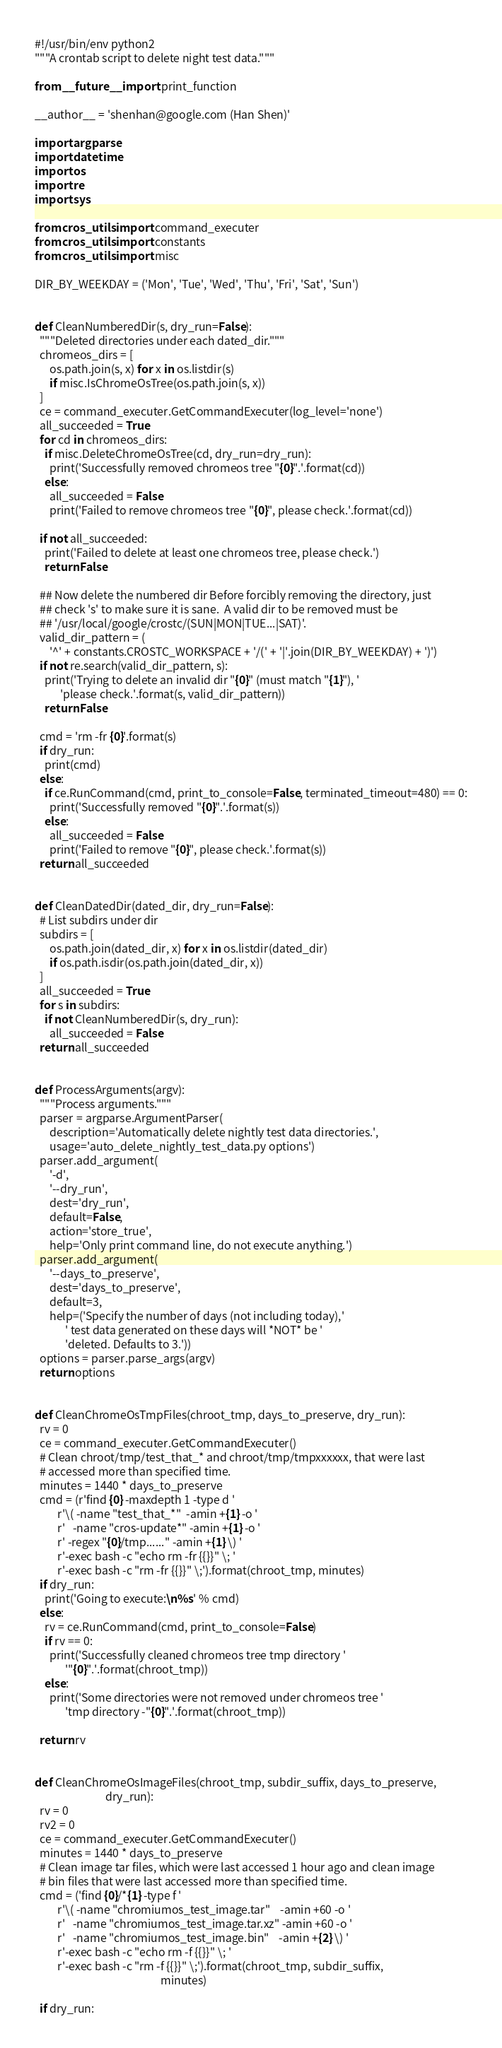<code> <loc_0><loc_0><loc_500><loc_500><_Python_>#!/usr/bin/env python2
"""A crontab script to delete night test data."""

from __future__ import print_function

__author__ = 'shenhan@google.com (Han Shen)'

import argparse
import datetime
import os
import re
import sys

from cros_utils import command_executer
from cros_utils import constants
from cros_utils import misc

DIR_BY_WEEKDAY = ('Mon', 'Tue', 'Wed', 'Thu', 'Fri', 'Sat', 'Sun')


def CleanNumberedDir(s, dry_run=False):
  """Deleted directories under each dated_dir."""
  chromeos_dirs = [
      os.path.join(s, x) for x in os.listdir(s)
      if misc.IsChromeOsTree(os.path.join(s, x))
  ]
  ce = command_executer.GetCommandExecuter(log_level='none')
  all_succeeded = True
  for cd in chromeos_dirs:
    if misc.DeleteChromeOsTree(cd, dry_run=dry_run):
      print('Successfully removed chromeos tree "{0}".'.format(cd))
    else:
      all_succeeded = False
      print('Failed to remove chromeos tree "{0}", please check.'.format(cd))

  if not all_succeeded:
    print('Failed to delete at least one chromeos tree, please check.')
    return False

  ## Now delete the numbered dir Before forcibly removing the directory, just
  ## check 's' to make sure it is sane.  A valid dir to be removed must be
  ## '/usr/local/google/crostc/(SUN|MON|TUE...|SAT)'.
  valid_dir_pattern = (
      '^' + constants.CROSTC_WORKSPACE + '/(' + '|'.join(DIR_BY_WEEKDAY) + ')')
  if not re.search(valid_dir_pattern, s):
    print('Trying to delete an invalid dir "{0}" (must match "{1}"), '
          'please check.'.format(s, valid_dir_pattern))
    return False

  cmd = 'rm -fr {0}'.format(s)
  if dry_run:
    print(cmd)
  else:
    if ce.RunCommand(cmd, print_to_console=False, terminated_timeout=480) == 0:
      print('Successfully removed "{0}".'.format(s))
    else:
      all_succeeded = False
      print('Failed to remove "{0}", please check.'.format(s))
  return all_succeeded


def CleanDatedDir(dated_dir, dry_run=False):
  # List subdirs under dir
  subdirs = [
      os.path.join(dated_dir, x) for x in os.listdir(dated_dir)
      if os.path.isdir(os.path.join(dated_dir, x))
  ]
  all_succeeded = True
  for s in subdirs:
    if not CleanNumberedDir(s, dry_run):
      all_succeeded = False
  return all_succeeded


def ProcessArguments(argv):
  """Process arguments."""
  parser = argparse.ArgumentParser(
      description='Automatically delete nightly test data directories.',
      usage='auto_delete_nightly_test_data.py options')
  parser.add_argument(
      '-d',
      '--dry_run',
      dest='dry_run',
      default=False,
      action='store_true',
      help='Only print command line, do not execute anything.')
  parser.add_argument(
      '--days_to_preserve',
      dest='days_to_preserve',
      default=3,
      help=('Specify the number of days (not including today),'
            ' test data generated on these days will *NOT* be '
            'deleted. Defaults to 3.'))
  options = parser.parse_args(argv)
  return options


def CleanChromeOsTmpFiles(chroot_tmp, days_to_preserve, dry_run):
  rv = 0
  ce = command_executer.GetCommandExecuter()
  # Clean chroot/tmp/test_that_* and chroot/tmp/tmpxxxxxx, that were last
  # accessed more than specified time.
  minutes = 1440 * days_to_preserve
  cmd = (r'find {0} -maxdepth 1 -type d '
         r'\( -name "test_that_*"  -amin +{1} -o '
         r'   -name "cros-update*" -amin +{1} -o '
         r' -regex "{0}/tmp......" -amin +{1} \) '
         r'-exec bash -c "echo rm -fr {{}}" \; '
         r'-exec bash -c "rm -fr {{}}" \;').format(chroot_tmp, minutes)
  if dry_run:
    print('Going to execute:\n%s' % cmd)
  else:
    rv = ce.RunCommand(cmd, print_to_console=False)
    if rv == 0:
      print('Successfully cleaned chromeos tree tmp directory '
            '"{0}".'.format(chroot_tmp))
    else:
      print('Some directories were not removed under chromeos tree '
            'tmp directory -"{0}".'.format(chroot_tmp))

  return rv


def CleanChromeOsImageFiles(chroot_tmp, subdir_suffix, days_to_preserve,
                            dry_run):
  rv = 0
  rv2 = 0
  ce = command_executer.GetCommandExecuter()
  minutes = 1440 * days_to_preserve
  # Clean image tar files, which were last accessed 1 hour ago and clean image
  # bin files that were last accessed more than specified time.
  cmd = ('find {0}/*{1} -type f '
         r'\( -name "chromiumos_test_image.tar"    -amin +60 -o '
         r'   -name "chromiumos_test_image.tar.xz" -amin +60 -o '
         r'   -name "chromiumos_test_image.bin"    -amin +{2} \) '
         r'-exec bash -c "echo rm -f {{}}" \; '
         r'-exec bash -c "rm -f {{}}" \;').format(chroot_tmp, subdir_suffix,
                                                  minutes)

  if dry_run:</code> 